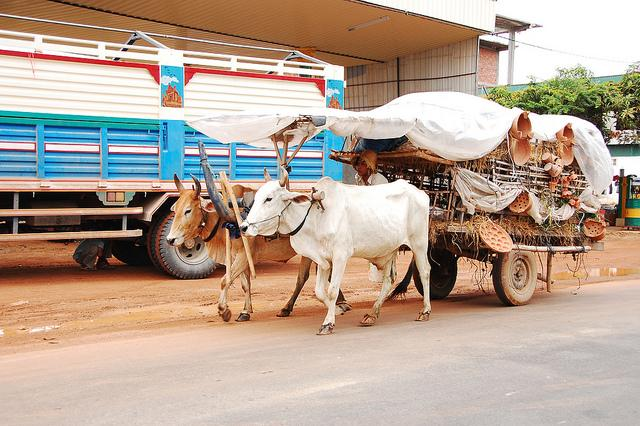What are the bulls doing? pulling cart 